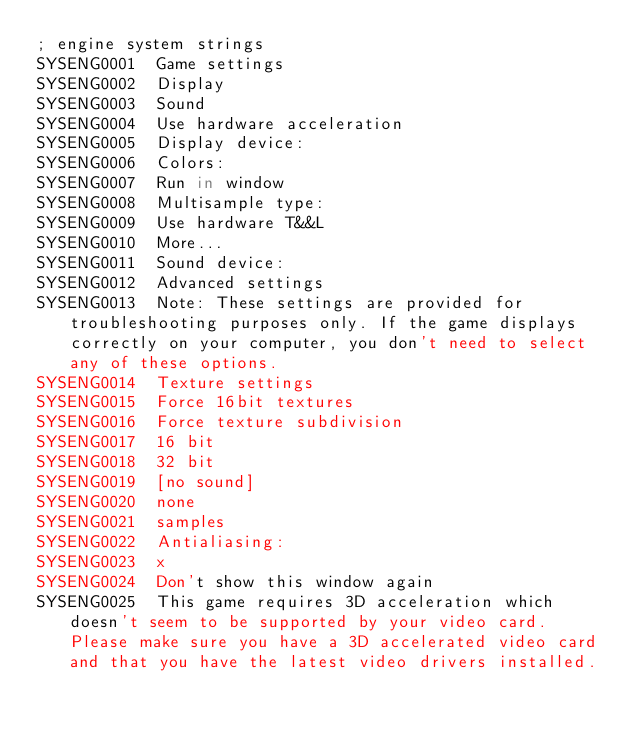<code> <loc_0><loc_0><loc_500><loc_500><_SQL_>; engine system strings
SYSENG0001	Game settings
SYSENG0002	Display
SYSENG0003	Sound
SYSENG0004	Use hardware acceleration
SYSENG0005	Display device:
SYSENG0006	Colors:
SYSENG0007	Run in window
SYSENG0008	Multisample type:
SYSENG0009	Use hardware T&&L
SYSENG0010	More...
SYSENG0011	Sound device:
SYSENG0012	Advanced settings
SYSENG0013	Note: These settings are provided for troubleshooting purposes only. If the game displays correctly on your computer, you don't need to select any of these options.
SYSENG0014	Texture settings
SYSENG0015	Force 16bit textures
SYSENG0016	Force texture subdivision
SYSENG0017	16 bit
SYSENG0018	32 bit
SYSENG0019	[no sound]
SYSENG0020	none
SYSENG0021	samples
SYSENG0022	Antialiasing:
SYSENG0023	x
SYSENG0024	Don't show this window again
SYSENG0025	This game requires 3D acceleration which doesn't seem to be supported by your video card. Please make sure you have a 3D accelerated video card and that you have the latest video drivers installed.</code> 